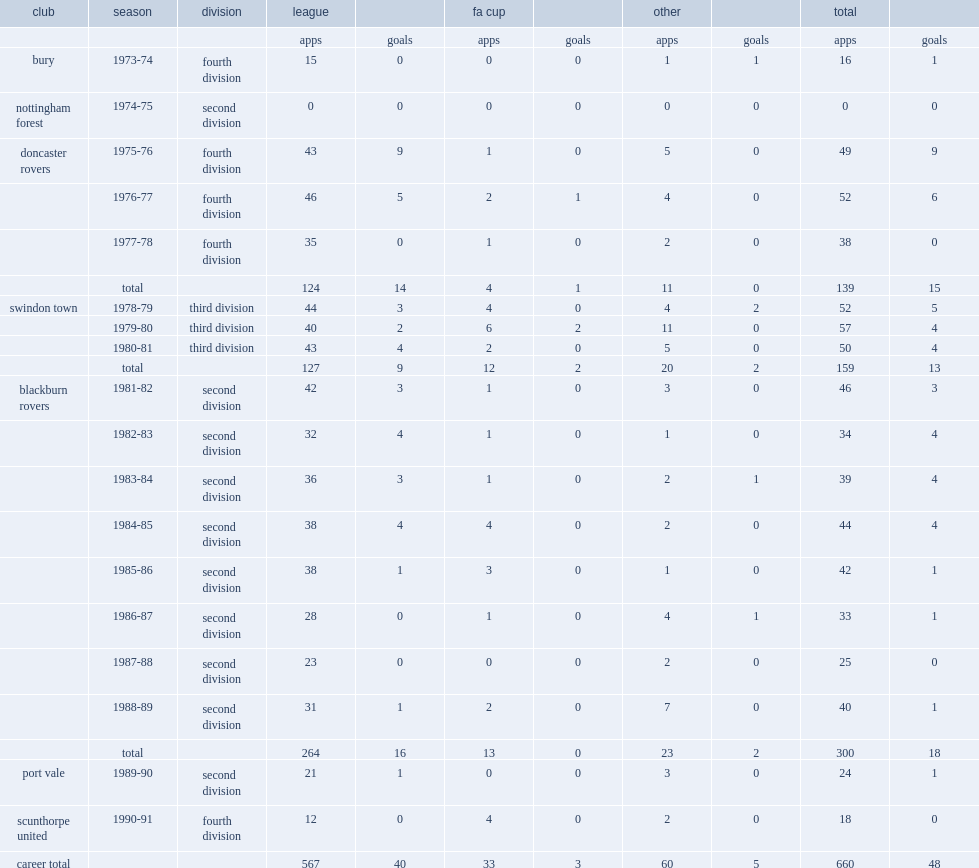Which club did ian miller play for bury in 1973-74? Bury. 